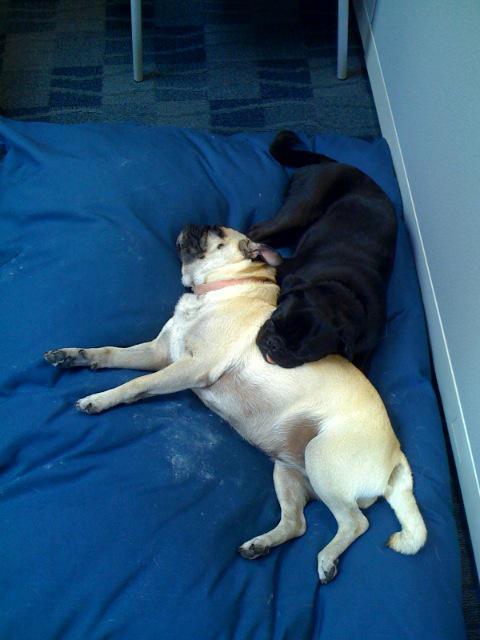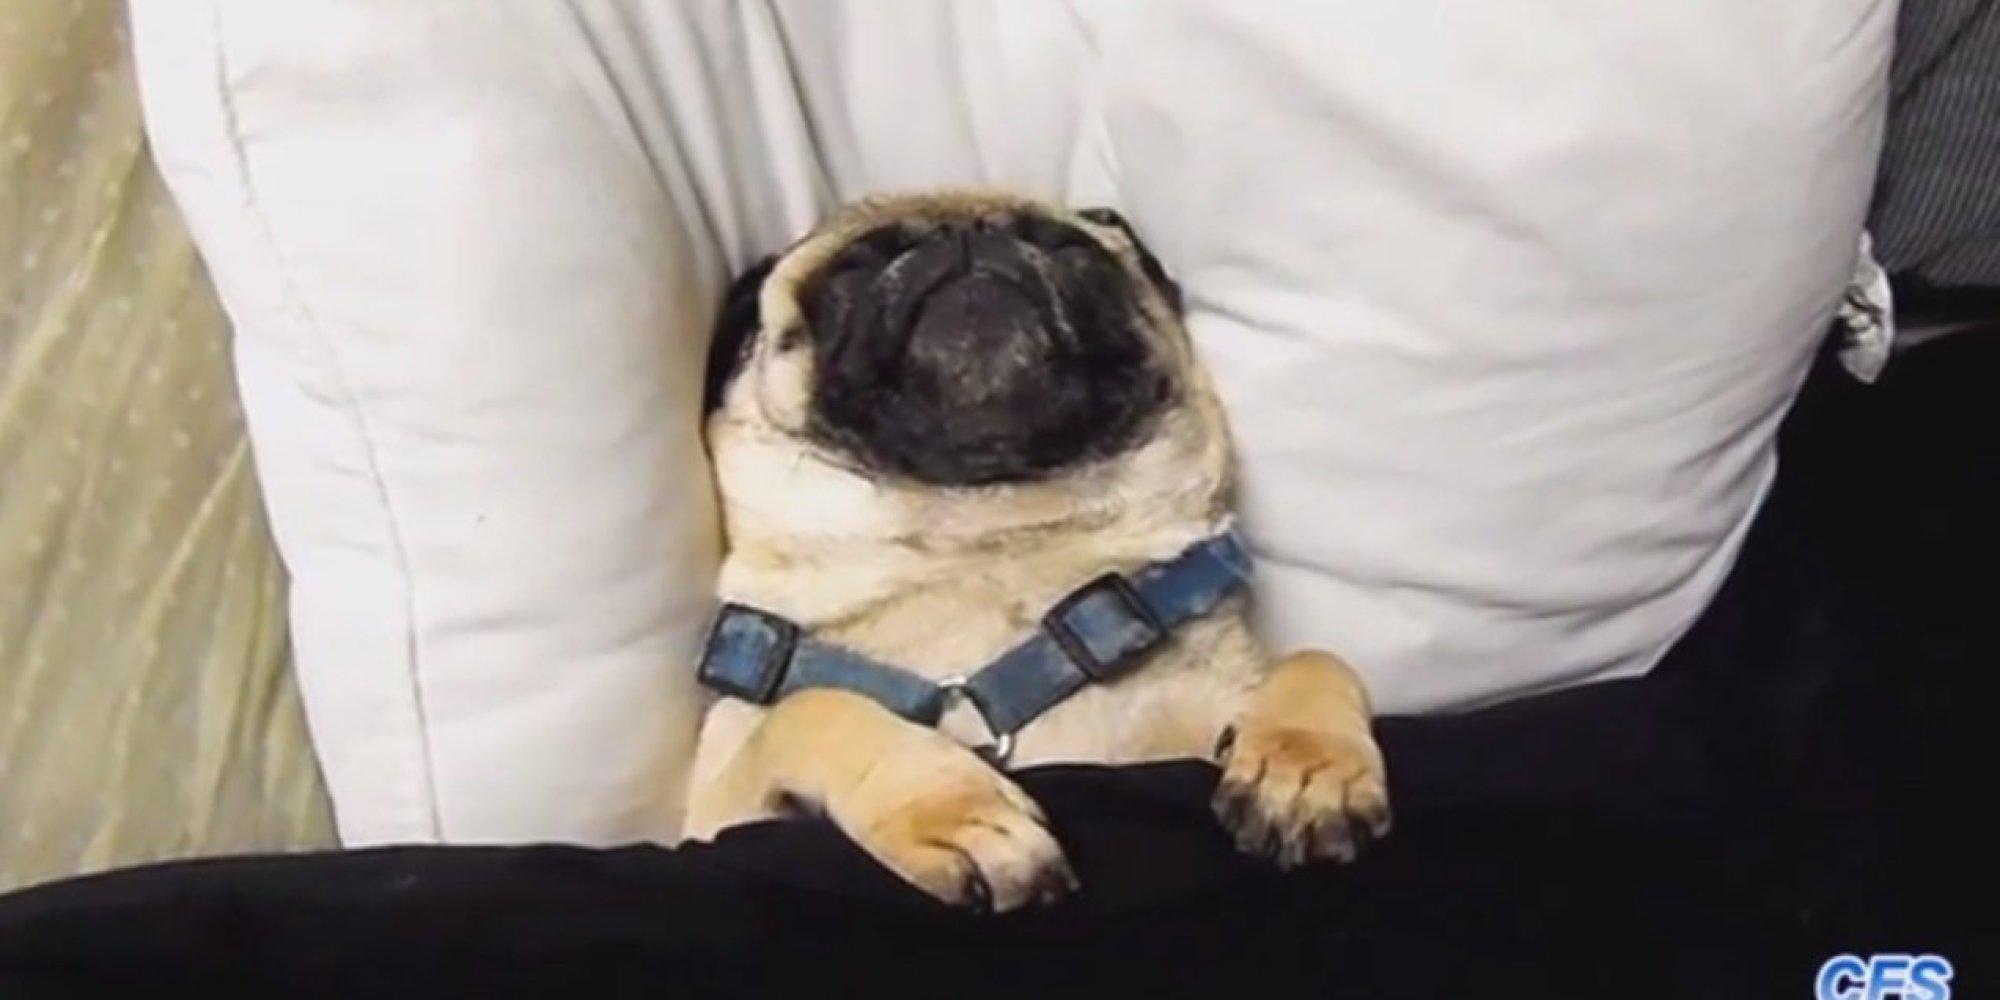The first image is the image on the left, the second image is the image on the right. Analyze the images presented: Is the assertion "One of the images has more than one dog." valid? Answer yes or no. Yes. The first image is the image on the left, the second image is the image on the right. Analyze the images presented: Is the assertion "Each image contains one buff-beige pug with a dark muzzle, and one pug is on an orange cushion while the other is lying flat on its belly." valid? Answer yes or no. No. 